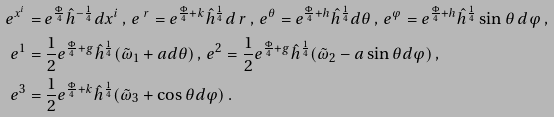Convert formula to latex. <formula><loc_0><loc_0><loc_500><loc_500>e ^ { x ^ { i } } & = e ^ { \frac { \Phi } { 4 } } \hat { h } ^ { - \frac { 1 } { 4 } } d x ^ { i } \, , \, e ^ { \ r } = e ^ { \frac { \Phi } { 4 } + k } \hat { h } ^ { \frac { 1 } { 4 } } d \ r \, , \, e ^ { \theta } = e ^ { \frac { \Phi } { 4 } + h } \hat { h } ^ { \frac { 1 } { 4 } } d \theta \, , \, e ^ { \varphi } = e ^ { \frac { \Phi } { 4 } + h } \hat { h } ^ { \frac { 1 } { 4 } } \sin \theta \, d \varphi \, , \\ e ^ { 1 } & = \frac { 1 } { 2 } e ^ { \frac { \Phi } { 4 } + g } \hat { h } ^ { \frac { 1 } { 4 } } ( \tilde { \omega } _ { 1 } + a d \theta ) \, , \, e ^ { 2 } = \frac { 1 } { 2 } e ^ { \frac { \Phi } { 4 } + g } \hat { h } ^ { \frac { 1 } { 4 } } ( \tilde { \omega } _ { 2 } - a \sin \theta d \varphi ) \, , \\ e ^ { 3 } & = \frac { 1 } { 2 } e ^ { \frac { \Phi } { 4 } + k } \hat { h } ^ { \frac { 1 } { 4 } } ( \tilde { \omega } _ { 3 } + \cos \theta d \varphi ) \, .</formula> 